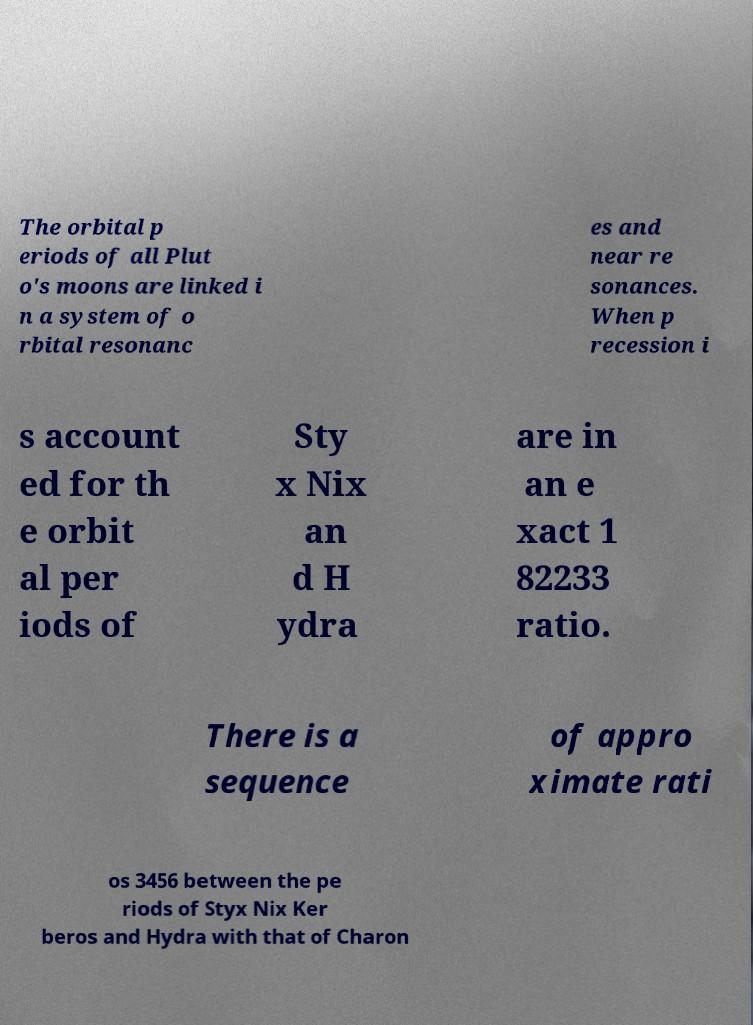Could you assist in decoding the text presented in this image and type it out clearly? The orbital p eriods of all Plut o's moons are linked i n a system of o rbital resonanc es and near re sonances. When p recession i s account ed for th e orbit al per iods of Sty x Nix an d H ydra are in an e xact 1 82233 ratio. There is a sequence of appro ximate rati os 3456 between the pe riods of Styx Nix Ker beros and Hydra with that of Charon 